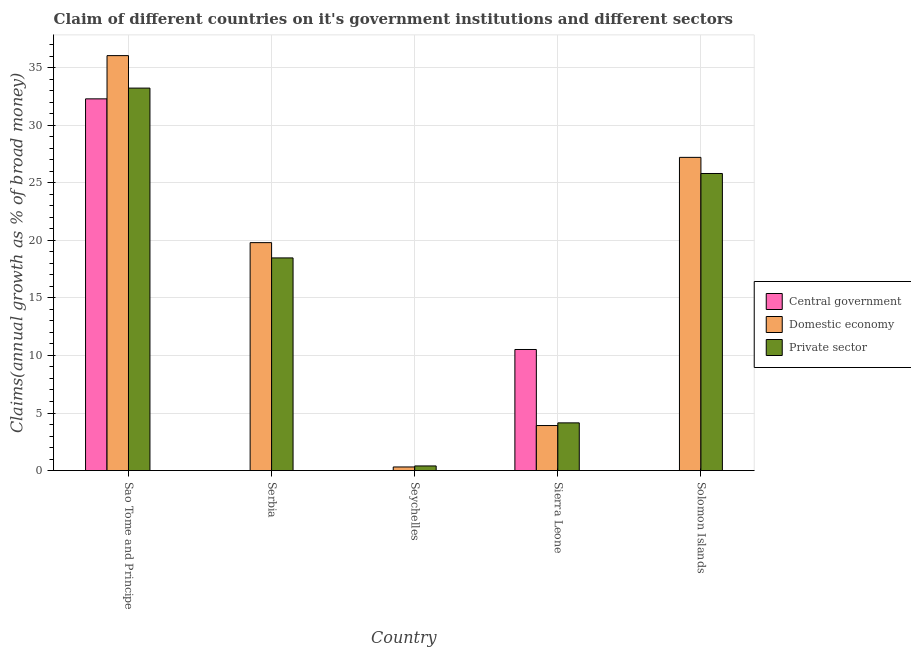How many groups of bars are there?
Offer a very short reply. 5. Are the number of bars per tick equal to the number of legend labels?
Your response must be concise. No. How many bars are there on the 2nd tick from the left?
Your answer should be compact. 2. What is the label of the 4th group of bars from the left?
Your answer should be very brief. Sierra Leone. In how many cases, is the number of bars for a given country not equal to the number of legend labels?
Your answer should be compact. 3. What is the percentage of claim on the central government in Seychelles?
Provide a short and direct response. 0. Across all countries, what is the maximum percentage of claim on the central government?
Provide a short and direct response. 32.28. Across all countries, what is the minimum percentage of claim on the domestic economy?
Give a very brief answer. 0.31. In which country was the percentage of claim on the private sector maximum?
Ensure brevity in your answer.  Sao Tome and Principe. What is the total percentage of claim on the private sector in the graph?
Offer a terse response. 82.03. What is the difference between the percentage of claim on the private sector in Serbia and that in Solomon Islands?
Offer a terse response. -7.33. What is the difference between the percentage of claim on the domestic economy in Seychelles and the percentage of claim on the private sector in Sao Tome and Principe?
Give a very brief answer. -32.9. What is the average percentage of claim on the private sector per country?
Your answer should be compact. 16.41. What is the difference between the percentage of claim on the private sector and percentage of claim on the central government in Sierra Leone?
Provide a short and direct response. -6.37. What is the ratio of the percentage of claim on the domestic economy in Sao Tome and Principe to that in Solomon Islands?
Your answer should be compact. 1.32. What is the difference between the highest and the second highest percentage of claim on the private sector?
Keep it short and to the point. 7.42. What is the difference between the highest and the lowest percentage of claim on the domestic economy?
Your response must be concise. 35.72. Is the sum of the percentage of claim on the private sector in Sierra Leone and Solomon Islands greater than the maximum percentage of claim on the central government across all countries?
Ensure brevity in your answer.  No. Is it the case that in every country, the sum of the percentage of claim on the central government and percentage of claim on the domestic economy is greater than the percentage of claim on the private sector?
Offer a very short reply. No. How many bars are there?
Give a very brief answer. 12. Are all the bars in the graph horizontal?
Provide a succinct answer. No. How many countries are there in the graph?
Your response must be concise. 5. Are the values on the major ticks of Y-axis written in scientific E-notation?
Keep it short and to the point. No. Does the graph contain any zero values?
Your response must be concise. Yes. Where does the legend appear in the graph?
Offer a terse response. Center right. How are the legend labels stacked?
Keep it short and to the point. Vertical. What is the title of the graph?
Make the answer very short. Claim of different countries on it's government institutions and different sectors. Does "Transport" appear as one of the legend labels in the graph?
Make the answer very short. No. What is the label or title of the X-axis?
Keep it short and to the point. Country. What is the label or title of the Y-axis?
Your answer should be compact. Claims(annual growth as % of broad money). What is the Claims(annual growth as % of broad money) of Central government in Sao Tome and Principe?
Give a very brief answer. 32.28. What is the Claims(annual growth as % of broad money) of Domestic economy in Sao Tome and Principe?
Give a very brief answer. 36.04. What is the Claims(annual growth as % of broad money) in Private sector in Sao Tome and Principe?
Your answer should be very brief. 33.22. What is the Claims(annual growth as % of broad money) in Central government in Serbia?
Provide a succinct answer. 0. What is the Claims(annual growth as % of broad money) in Domestic economy in Serbia?
Provide a short and direct response. 19.8. What is the Claims(annual growth as % of broad money) in Private sector in Serbia?
Give a very brief answer. 18.47. What is the Claims(annual growth as % of broad money) of Central government in Seychelles?
Make the answer very short. 0. What is the Claims(annual growth as % of broad money) of Domestic economy in Seychelles?
Ensure brevity in your answer.  0.31. What is the Claims(annual growth as % of broad money) in Private sector in Seychelles?
Your answer should be compact. 0.4. What is the Claims(annual growth as % of broad money) in Central government in Sierra Leone?
Make the answer very short. 10.52. What is the Claims(annual growth as % of broad money) of Domestic economy in Sierra Leone?
Offer a terse response. 3.91. What is the Claims(annual growth as % of broad money) of Private sector in Sierra Leone?
Offer a very short reply. 4.14. What is the Claims(annual growth as % of broad money) of Central government in Solomon Islands?
Keep it short and to the point. 0. What is the Claims(annual growth as % of broad money) of Domestic economy in Solomon Islands?
Your answer should be very brief. 27.2. What is the Claims(annual growth as % of broad money) of Private sector in Solomon Islands?
Offer a terse response. 25.8. Across all countries, what is the maximum Claims(annual growth as % of broad money) in Central government?
Ensure brevity in your answer.  32.28. Across all countries, what is the maximum Claims(annual growth as % of broad money) of Domestic economy?
Provide a succinct answer. 36.04. Across all countries, what is the maximum Claims(annual growth as % of broad money) in Private sector?
Your response must be concise. 33.22. Across all countries, what is the minimum Claims(annual growth as % of broad money) in Domestic economy?
Your answer should be compact. 0.31. Across all countries, what is the minimum Claims(annual growth as % of broad money) of Private sector?
Your answer should be very brief. 0.4. What is the total Claims(annual growth as % of broad money) in Central government in the graph?
Give a very brief answer. 42.8. What is the total Claims(annual growth as % of broad money) in Domestic economy in the graph?
Keep it short and to the point. 87.26. What is the total Claims(annual growth as % of broad money) of Private sector in the graph?
Offer a terse response. 82.03. What is the difference between the Claims(annual growth as % of broad money) in Domestic economy in Sao Tome and Principe and that in Serbia?
Ensure brevity in your answer.  16.24. What is the difference between the Claims(annual growth as % of broad money) of Private sector in Sao Tome and Principe and that in Serbia?
Your answer should be compact. 14.75. What is the difference between the Claims(annual growth as % of broad money) in Domestic economy in Sao Tome and Principe and that in Seychelles?
Your answer should be very brief. 35.72. What is the difference between the Claims(annual growth as % of broad money) of Private sector in Sao Tome and Principe and that in Seychelles?
Make the answer very short. 32.81. What is the difference between the Claims(annual growth as % of broad money) of Central government in Sao Tome and Principe and that in Sierra Leone?
Offer a very short reply. 21.77. What is the difference between the Claims(annual growth as % of broad money) in Domestic economy in Sao Tome and Principe and that in Sierra Leone?
Keep it short and to the point. 32.13. What is the difference between the Claims(annual growth as % of broad money) of Private sector in Sao Tome and Principe and that in Sierra Leone?
Make the answer very short. 29.07. What is the difference between the Claims(annual growth as % of broad money) of Domestic economy in Sao Tome and Principe and that in Solomon Islands?
Keep it short and to the point. 8.84. What is the difference between the Claims(annual growth as % of broad money) in Private sector in Sao Tome and Principe and that in Solomon Islands?
Make the answer very short. 7.42. What is the difference between the Claims(annual growth as % of broad money) of Domestic economy in Serbia and that in Seychelles?
Keep it short and to the point. 19.48. What is the difference between the Claims(annual growth as % of broad money) in Private sector in Serbia and that in Seychelles?
Your answer should be compact. 18.07. What is the difference between the Claims(annual growth as % of broad money) of Domestic economy in Serbia and that in Sierra Leone?
Your answer should be very brief. 15.89. What is the difference between the Claims(annual growth as % of broad money) of Private sector in Serbia and that in Sierra Leone?
Your response must be concise. 14.33. What is the difference between the Claims(annual growth as % of broad money) of Domestic economy in Serbia and that in Solomon Islands?
Keep it short and to the point. -7.41. What is the difference between the Claims(annual growth as % of broad money) in Private sector in Serbia and that in Solomon Islands?
Ensure brevity in your answer.  -7.33. What is the difference between the Claims(annual growth as % of broad money) in Domestic economy in Seychelles and that in Sierra Leone?
Give a very brief answer. -3.6. What is the difference between the Claims(annual growth as % of broad money) in Private sector in Seychelles and that in Sierra Leone?
Ensure brevity in your answer.  -3.74. What is the difference between the Claims(annual growth as % of broad money) of Domestic economy in Seychelles and that in Solomon Islands?
Offer a very short reply. -26.89. What is the difference between the Claims(annual growth as % of broad money) in Private sector in Seychelles and that in Solomon Islands?
Keep it short and to the point. -25.4. What is the difference between the Claims(annual growth as % of broad money) in Domestic economy in Sierra Leone and that in Solomon Islands?
Your answer should be compact. -23.29. What is the difference between the Claims(annual growth as % of broad money) in Private sector in Sierra Leone and that in Solomon Islands?
Ensure brevity in your answer.  -21.66. What is the difference between the Claims(annual growth as % of broad money) in Central government in Sao Tome and Principe and the Claims(annual growth as % of broad money) in Domestic economy in Serbia?
Ensure brevity in your answer.  12.49. What is the difference between the Claims(annual growth as % of broad money) of Central government in Sao Tome and Principe and the Claims(annual growth as % of broad money) of Private sector in Serbia?
Your answer should be compact. 13.81. What is the difference between the Claims(annual growth as % of broad money) in Domestic economy in Sao Tome and Principe and the Claims(annual growth as % of broad money) in Private sector in Serbia?
Provide a succinct answer. 17.57. What is the difference between the Claims(annual growth as % of broad money) of Central government in Sao Tome and Principe and the Claims(annual growth as % of broad money) of Domestic economy in Seychelles?
Offer a very short reply. 31.97. What is the difference between the Claims(annual growth as % of broad money) in Central government in Sao Tome and Principe and the Claims(annual growth as % of broad money) in Private sector in Seychelles?
Make the answer very short. 31.88. What is the difference between the Claims(annual growth as % of broad money) in Domestic economy in Sao Tome and Principe and the Claims(annual growth as % of broad money) in Private sector in Seychelles?
Your answer should be compact. 35.64. What is the difference between the Claims(annual growth as % of broad money) of Central government in Sao Tome and Principe and the Claims(annual growth as % of broad money) of Domestic economy in Sierra Leone?
Ensure brevity in your answer.  28.37. What is the difference between the Claims(annual growth as % of broad money) of Central government in Sao Tome and Principe and the Claims(annual growth as % of broad money) of Private sector in Sierra Leone?
Give a very brief answer. 28.14. What is the difference between the Claims(annual growth as % of broad money) of Domestic economy in Sao Tome and Principe and the Claims(annual growth as % of broad money) of Private sector in Sierra Leone?
Ensure brevity in your answer.  31.89. What is the difference between the Claims(annual growth as % of broad money) in Central government in Sao Tome and Principe and the Claims(annual growth as % of broad money) in Domestic economy in Solomon Islands?
Offer a terse response. 5.08. What is the difference between the Claims(annual growth as % of broad money) in Central government in Sao Tome and Principe and the Claims(annual growth as % of broad money) in Private sector in Solomon Islands?
Your response must be concise. 6.48. What is the difference between the Claims(annual growth as % of broad money) of Domestic economy in Sao Tome and Principe and the Claims(annual growth as % of broad money) of Private sector in Solomon Islands?
Ensure brevity in your answer.  10.24. What is the difference between the Claims(annual growth as % of broad money) of Domestic economy in Serbia and the Claims(annual growth as % of broad money) of Private sector in Seychelles?
Your answer should be very brief. 19.39. What is the difference between the Claims(annual growth as % of broad money) of Domestic economy in Serbia and the Claims(annual growth as % of broad money) of Private sector in Sierra Leone?
Offer a very short reply. 15.65. What is the difference between the Claims(annual growth as % of broad money) of Domestic economy in Serbia and the Claims(annual growth as % of broad money) of Private sector in Solomon Islands?
Make the answer very short. -6. What is the difference between the Claims(annual growth as % of broad money) in Domestic economy in Seychelles and the Claims(annual growth as % of broad money) in Private sector in Sierra Leone?
Offer a very short reply. -3.83. What is the difference between the Claims(annual growth as % of broad money) of Domestic economy in Seychelles and the Claims(annual growth as % of broad money) of Private sector in Solomon Islands?
Ensure brevity in your answer.  -25.49. What is the difference between the Claims(annual growth as % of broad money) of Central government in Sierra Leone and the Claims(annual growth as % of broad money) of Domestic economy in Solomon Islands?
Provide a succinct answer. -16.69. What is the difference between the Claims(annual growth as % of broad money) in Central government in Sierra Leone and the Claims(annual growth as % of broad money) in Private sector in Solomon Islands?
Offer a very short reply. -15.28. What is the difference between the Claims(annual growth as % of broad money) of Domestic economy in Sierra Leone and the Claims(annual growth as % of broad money) of Private sector in Solomon Islands?
Offer a very short reply. -21.89. What is the average Claims(annual growth as % of broad money) of Central government per country?
Provide a succinct answer. 8.56. What is the average Claims(annual growth as % of broad money) of Domestic economy per country?
Your answer should be very brief. 17.45. What is the average Claims(annual growth as % of broad money) in Private sector per country?
Give a very brief answer. 16.41. What is the difference between the Claims(annual growth as % of broad money) of Central government and Claims(annual growth as % of broad money) of Domestic economy in Sao Tome and Principe?
Give a very brief answer. -3.75. What is the difference between the Claims(annual growth as % of broad money) in Central government and Claims(annual growth as % of broad money) in Private sector in Sao Tome and Principe?
Provide a succinct answer. -0.93. What is the difference between the Claims(annual growth as % of broad money) of Domestic economy and Claims(annual growth as % of broad money) of Private sector in Sao Tome and Principe?
Provide a succinct answer. 2.82. What is the difference between the Claims(annual growth as % of broad money) of Domestic economy and Claims(annual growth as % of broad money) of Private sector in Serbia?
Offer a terse response. 1.33. What is the difference between the Claims(annual growth as % of broad money) of Domestic economy and Claims(annual growth as % of broad money) of Private sector in Seychelles?
Your answer should be compact. -0.09. What is the difference between the Claims(annual growth as % of broad money) in Central government and Claims(annual growth as % of broad money) in Domestic economy in Sierra Leone?
Make the answer very short. 6.6. What is the difference between the Claims(annual growth as % of broad money) of Central government and Claims(annual growth as % of broad money) of Private sector in Sierra Leone?
Offer a terse response. 6.37. What is the difference between the Claims(annual growth as % of broad money) of Domestic economy and Claims(annual growth as % of broad money) of Private sector in Sierra Leone?
Your answer should be compact. -0.23. What is the difference between the Claims(annual growth as % of broad money) of Domestic economy and Claims(annual growth as % of broad money) of Private sector in Solomon Islands?
Provide a succinct answer. 1.4. What is the ratio of the Claims(annual growth as % of broad money) of Domestic economy in Sao Tome and Principe to that in Serbia?
Your answer should be very brief. 1.82. What is the ratio of the Claims(annual growth as % of broad money) of Private sector in Sao Tome and Principe to that in Serbia?
Your answer should be compact. 1.8. What is the ratio of the Claims(annual growth as % of broad money) of Domestic economy in Sao Tome and Principe to that in Seychelles?
Your answer should be compact. 114.94. What is the ratio of the Claims(annual growth as % of broad money) in Private sector in Sao Tome and Principe to that in Seychelles?
Make the answer very short. 82.51. What is the ratio of the Claims(annual growth as % of broad money) of Central government in Sao Tome and Principe to that in Sierra Leone?
Provide a succinct answer. 3.07. What is the ratio of the Claims(annual growth as % of broad money) in Domestic economy in Sao Tome and Principe to that in Sierra Leone?
Your response must be concise. 9.21. What is the ratio of the Claims(annual growth as % of broad money) of Private sector in Sao Tome and Principe to that in Sierra Leone?
Provide a short and direct response. 8.02. What is the ratio of the Claims(annual growth as % of broad money) of Domestic economy in Sao Tome and Principe to that in Solomon Islands?
Keep it short and to the point. 1.32. What is the ratio of the Claims(annual growth as % of broad money) in Private sector in Sao Tome and Principe to that in Solomon Islands?
Provide a succinct answer. 1.29. What is the ratio of the Claims(annual growth as % of broad money) in Domestic economy in Serbia to that in Seychelles?
Your answer should be compact. 63.14. What is the ratio of the Claims(annual growth as % of broad money) of Private sector in Serbia to that in Seychelles?
Keep it short and to the point. 45.88. What is the ratio of the Claims(annual growth as % of broad money) in Domestic economy in Serbia to that in Sierra Leone?
Give a very brief answer. 5.06. What is the ratio of the Claims(annual growth as % of broad money) of Private sector in Serbia to that in Sierra Leone?
Give a very brief answer. 4.46. What is the ratio of the Claims(annual growth as % of broad money) of Domestic economy in Serbia to that in Solomon Islands?
Provide a succinct answer. 0.73. What is the ratio of the Claims(annual growth as % of broad money) in Private sector in Serbia to that in Solomon Islands?
Offer a very short reply. 0.72. What is the ratio of the Claims(annual growth as % of broad money) of Domestic economy in Seychelles to that in Sierra Leone?
Your response must be concise. 0.08. What is the ratio of the Claims(annual growth as % of broad money) in Private sector in Seychelles to that in Sierra Leone?
Your answer should be very brief. 0.1. What is the ratio of the Claims(annual growth as % of broad money) in Domestic economy in Seychelles to that in Solomon Islands?
Ensure brevity in your answer.  0.01. What is the ratio of the Claims(annual growth as % of broad money) in Private sector in Seychelles to that in Solomon Islands?
Make the answer very short. 0.02. What is the ratio of the Claims(annual growth as % of broad money) of Domestic economy in Sierra Leone to that in Solomon Islands?
Your answer should be compact. 0.14. What is the ratio of the Claims(annual growth as % of broad money) of Private sector in Sierra Leone to that in Solomon Islands?
Make the answer very short. 0.16. What is the difference between the highest and the second highest Claims(annual growth as % of broad money) of Domestic economy?
Your answer should be very brief. 8.84. What is the difference between the highest and the second highest Claims(annual growth as % of broad money) in Private sector?
Offer a terse response. 7.42. What is the difference between the highest and the lowest Claims(annual growth as % of broad money) of Central government?
Offer a very short reply. 32.28. What is the difference between the highest and the lowest Claims(annual growth as % of broad money) in Domestic economy?
Your response must be concise. 35.72. What is the difference between the highest and the lowest Claims(annual growth as % of broad money) of Private sector?
Your response must be concise. 32.81. 